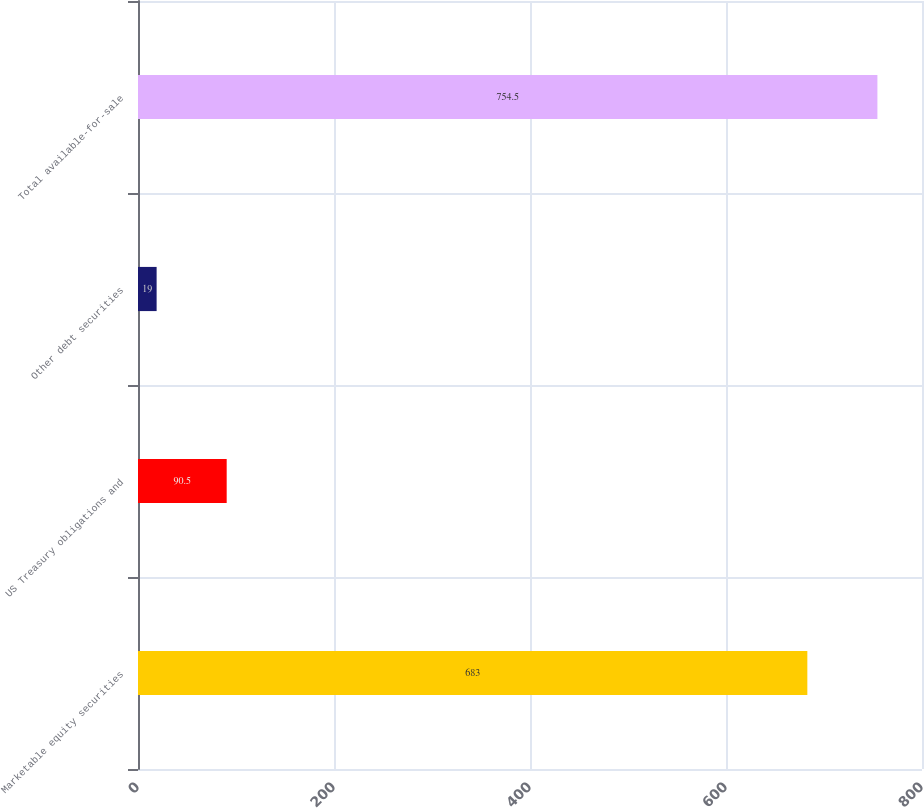Convert chart. <chart><loc_0><loc_0><loc_500><loc_500><bar_chart><fcel>Marketable equity securities<fcel>US Treasury obligations and<fcel>Other debt securities<fcel>Total available-for-sale<nl><fcel>683<fcel>90.5<fcel>19<fcel>754.5<nl></chart> 